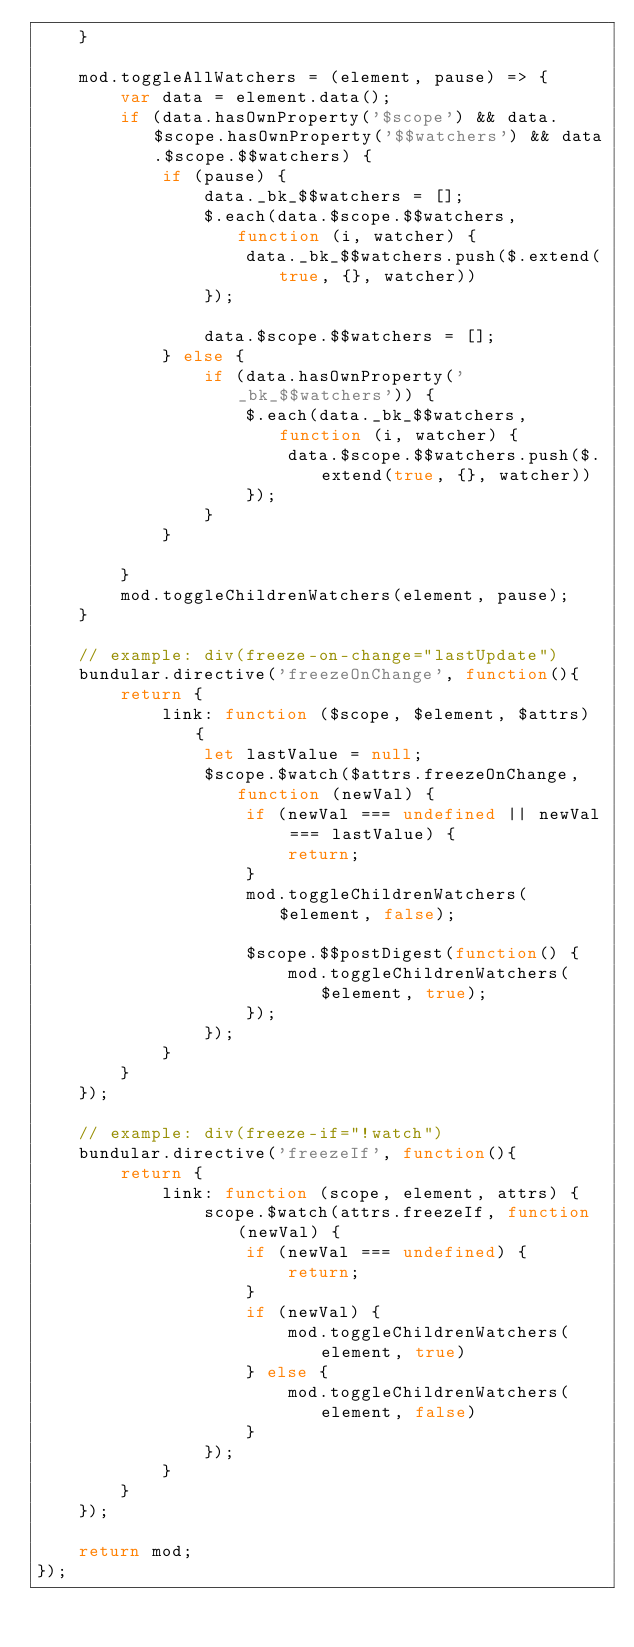<code> <loc_0><loc_0><loc_500><loc_500><_JavaScript_>	}

	mod.toggleAllWatchers = (element, pause) => {
		var data = element.data();
		if (data.hasOwnProperty('$scope') && data.$scope.hasOwnProperty('$$watchers') && data.$scope.$$watchers) {
			if (pause) {
				data._bk_$$watchers = [];
				$.each(data.$scope.$$watchers, function (i, watcher) {
					data._bk_$$watchers.push($.extend(true, {}, watcher))
				});

				data.$scope.$$watchers = [];
			} else {
				if (data.hasOwnProperty('_bk_$$watchers')) {
					$.each(data._bk_$$watchers, function (i, watcher) {
						data.$scope.$$watchers.push($.extend(true, {}, watcher))
					});
				}
			}

		}
		mod.toggleChildrenWatchers(element, pause);
	}

	// example: div(freeze-on-change="lastUpdate")
	bundular.directive('freezeOnChange', function(){
		return {
			link: function ($scope, $element, $attrs) {
				let lastValue = null;
				$scope.$watch($attrs.freezeOnChange, function (newVal) {
					if (newVal === undefined || newVal === lastValue) {
						return;
					}
					mod.toggleChildrenWatchers($element, false);

					$scope.$$postDigest(function() {
						mod.toggleChildrenWatchers($element, true);
					});
				});
			}
		}
	});

	// example: div(freeze-if="!watch")
	bundular.directive('freezeIf', function(){
		return {
			link: function (scope, element, attrs) {
				scope.$watch(attrs.freezeIf, function (newVal) {
					if (newVal === undefined) {
						return;
					}
					if (newVal) {
						mod.toggleChildrenWatchers(element, true)
					} else {
						mod.toggleChildrenWatchers(element, false)
					}
				});
			}
		}
	});

	return mod;
});</code> 